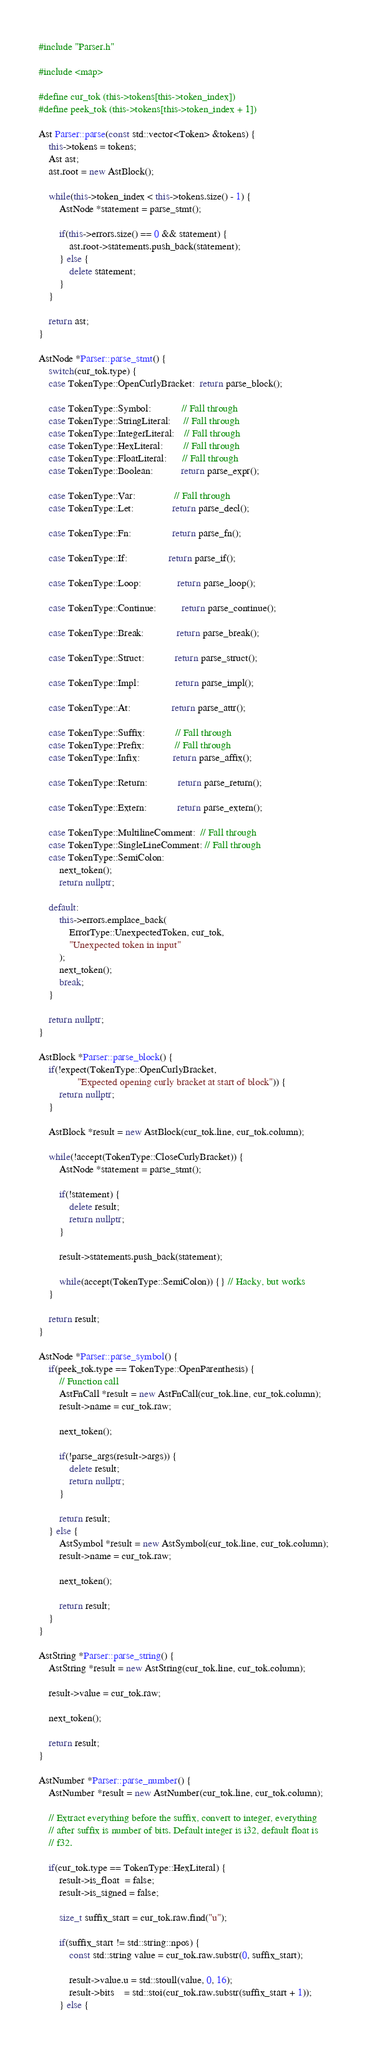Convert code to text. <code><loc_0><loc_0><loc_500><loc_500><_C++_>#include "Parser.h"

#include <map>

#define cur_tok (this->tokens[this->token_index])
#define peek_tok (this->tokens[this->token_index + 1])

Ast Parser::parse(const std::vector<Token> &tokens) {
    this->tokens = tokens;
    Ast ast;
    ast.root = new AstBlock();

    while(this->token_index < this->tokens.size() - 1) {
        AstNode *statement = parse_stmt();

        if(this->errors.size() == 0 && statement) {
            ast.root->statements.push_back(statement);
        } else {
            delete statement;
        }
    }

    return ast;
}

AstNode *Parser::parse_stmt() {
    switch(cur_tok.type) {
    case TokenType::OpenCurlyBracket:  return parse_block();

    case TokenType::Symbol:            // Fall through
    case TokenType::StringLiteral:     // Fall through
    case TokenType::IntegerLiteral:    // Fall through
    case TokenType::HexLiteral:        // Fall through
    case TokenType::FloatLiteral:      // Fall through
    case TokenType::Boolean:           return parse_expr();

    case TokenType::Var:               // Fall through
    case TokenType::Let:               return parse_decl();

    case TokenType::Fn:                return parse_fn();

    case TokenType::If:                return parse_if();

    case TokenType::Loop:              return parse_loop();

    case TokenType::Continue:          return parse_continue();

    case TokenType::Break:             return parse_break();

    case TokenType::Struct:            return parse_struct();

    case TokenType::Impl:              return parse_impl();

    case TokenType::At:                return parse_attr();

    case TokenType::Suffix:            // Fall through
    case TokenType::Prefix:            // Fall through
    case TokenType::Infix:             return parse_affix();

    case TokenType::Return:            return parse_return();

    case TokenType::Extern:            return parse_extern();

    case TokenType::MultilineComment:  // Fall through
    case TokenType::SingleLineComment: // Fall through
    case TokenType::SemiColon:
        next_token();
        return nullptr;

    default:
        this->errors.emplace_back(
            ErrorType::UnexpectedToken, cur_tok,
            "Unexpected token in input"
        );
        next_token();
        break;
    }

    return nullptr;
}

AstBlock *Parser::parse_block() {
    if(!expect(TokenType::OpenCurlyBracket,
               "Expected opening curly bracket at start of block")) {
        return nullptr;
    }

    AstBlock *result = new AstBlock(cur_tok.line, cur_tok.column);

    while(!accept(TokenType::CloseCurlyBracket)) {
        AstNode *statement = parse_stmt();

        if(!statement) {
            delete result;
            return nullptr;
        }

        result->statements.push_back(statement);

        while(accept(TokenType::SemiColon)) {} // Hacky, but works
    }

    return result;
}

AstNode *Parser::parse_symbol() {
    if(peek_tok.type == TokenType::OpenParenthesis) {
        // Function call
        AstFnCall *result = new AstFnCall(cur_tok.line, cur_tok.column);
        result->name = cur_tok.raw;

        next_token();

        if(!parse_args(result->args)) {
            delete result;
            return nullptr;
        }

        return result;
    } else {
        AstSymbol *result = new AstSymbol(cur_tok.line, cur_tok.column);
        result->name = cur_tok.raw;

        next_token();

        return result;
    }
}

AstString *Parser::parse_string() {
    AstString *result = new AstString(cur_tok.line, cur_tok.column);

    result->value = cur_tok.raw;

    next_token();

    return result;
}

AstNumber *Parser::parse_number() {
    AstNumber *result = new AstNumber(cur_tok.line, cur_tok.column);

    // Extract everything before the suffix, convert to integer, everything
    // after suffix is number of bits. Default integer is i32, default float is
    // f32.

    if(cur_tok.type == TokenType::HexLiteral) {
        result->is_float  = false;
        result->is_signed = false;

        size_t suffix_start = cur_tok.raw.find("u");

        if(suffix_start != std::string::npos) {
            const std::string value = cur_tok.raw.substr(0, suffix_start);

            result->value.u = std::stoull(value, 0, 16);
            result->bits    = std::stoi(cur_tok.raw.substr(suffix_start + 1));
        } else {</code> 